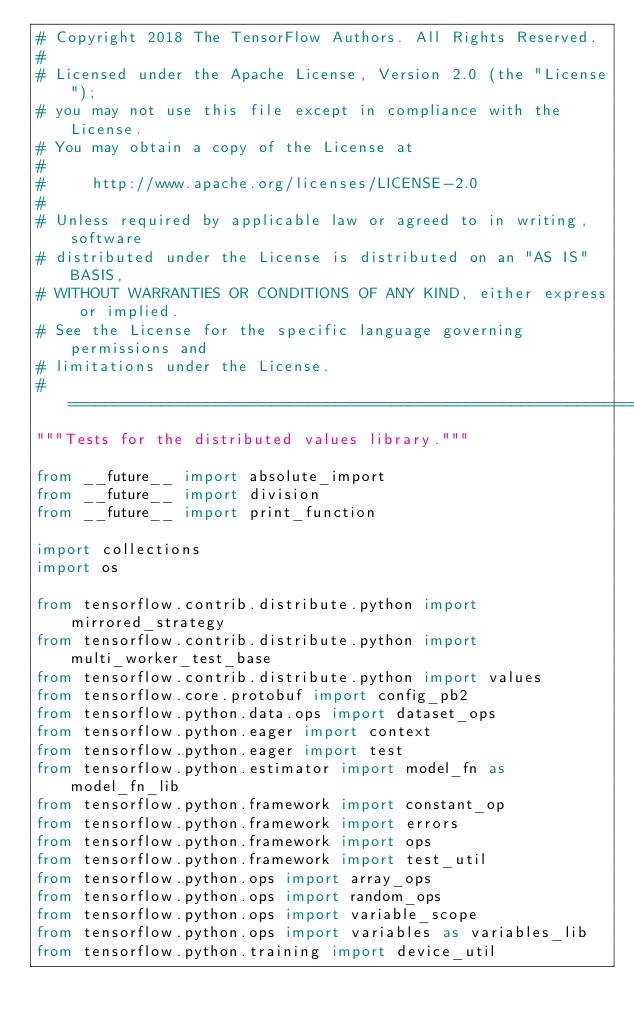Convert code to text. <code><loc_0><loc_0><loc_500><loc_500><_Python_># Copyright 2018 The TensorFlow Authors. All Rights Reserved.
#
# Licensed under the Apache License, Version 2.0 (the "License");
# you may not use this file except in compliance with the License.
# You may obtain a copy of the License at
#
#     http://www.apache.org/licenses/LICENSE-2.0
#
# Unless required by applicable law or agreed to in writing, software
# distributed under the License is distributed on an "AS IS" BASIS,
# WITHOUT WARRANTIES OR CONDITIONS OF ANY KIND, either express or implied.
# See the License for the specific language governing permissions and
# limitations under the License.
# ==============================================================================
"""Tests for the distributed values library."""

from __future__ import absolute_import
from __future__ import division
from __future__ import print_function

import collections
import os

from tensorflow.contrib.distribute.python import mirrored_strategy
from tensorflow.contrib.distribute.python import multi_worker_test_base
from tensorflow.contrib.distribute.python import values
from tensorflow.core.protobuf import config_pb2
from tensorflow.python.data.ops import dataset_ops
from tensorflow.python.eager import context
from tensorflow.python.eager import test
from tensorflow.python.estimator import model_fn as model_fn_lib
from tensorflow.python.framework import constant_op
from tensorflow.python.framework import errors
from tensorflow.python.framework import ops
from tensorflow.python.framework import test_util
from tensorflow.python.ops import array_ops
from tensorflow.python.ops import random_ops
from tensorflow.python.ops import variable_scope
from tensorflow.python.ops import variables as variables_lib
from tensorflow.python.training import device_util</code> 